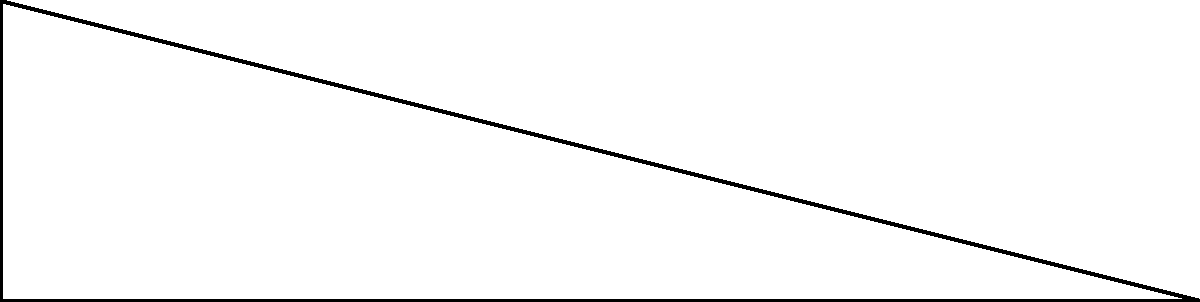A community center is planning to install a new wheelchair ramp. The building code requires the ramp to rise 1.5 meters over a horizontal distance of 6 meters. What is the angle of elevation ($\theta$) of the ramp to the nearest degree? To find the angle of elevation ($\theta$) of the wheelchair ramp, we can use the sine ratio in trigonometry. Here's how we solve it step by step:

1) In the right-angled triangle formed by the ramp:
   - The opposite side (rise) is 1.5 meters
   - The adjacent side (run) is 6 meters
   - We need to find the angle $\theta$

2) The sine ratio is defined as:
   $\sin(\theta) = \frac{\text{opposite}}{\text{hypotenuse}}$

3) However, we don't know the hypotenuse. But we can use the inverse sine function with the opposite and adjacent sides:
   $\sin(\theta) = \frac{\text{opposite}}{\text{adjacent}}$

4) Substituting our values:
   $\sin(\theta) = \frac{1.5}{6} = 0.25$

5) To find $\theta$, we take the inverse sine (arcsin) of both sides:
   $\theta = \arcsin(0.25)$

6) Using a calculator or trigonometric tables:
   $\theta \approx 14.48^\circ$

7) Rounding to the nearest degree:
   $\theta \approx 14^\circ$

Therefore, the angle of elevation of the wheelchair ramp is approximately 14 degrees.
Answer: $14^\circ$ 